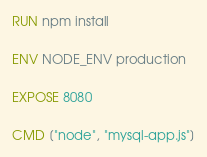<code> <loc_0><loc_0><loc_500><loc_500><_Dockerfile_>RUN npm install

ENV NODE_ENV production

EXPOSE 8080

CMD ["node", "mysql-app.js"]
</code> 